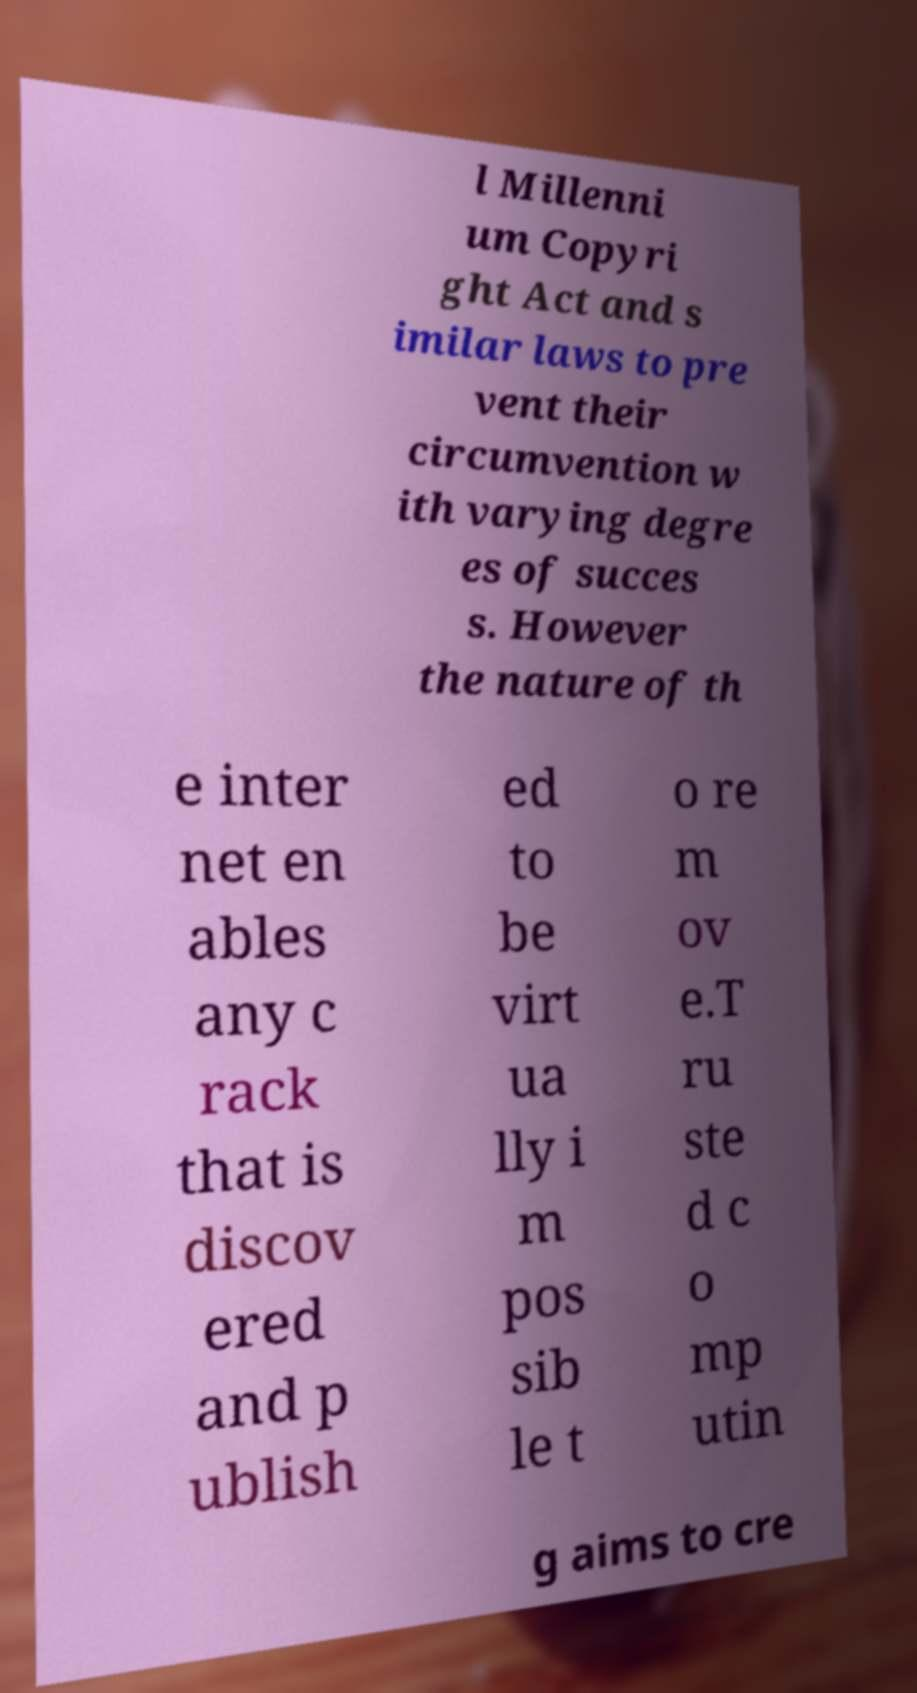Could you extract and type out the text from this image? l Millenni um Copyri ght Act and s imilar laws to pre vent their circumvention w ith varying degre es of succes s. However the nature of th e inter net en ables any c rack that is discov ered and p ublish ed to be virt ua lly i m pos sib le t o re m ov e.T ru ste d c o mp utin g aims to cre 